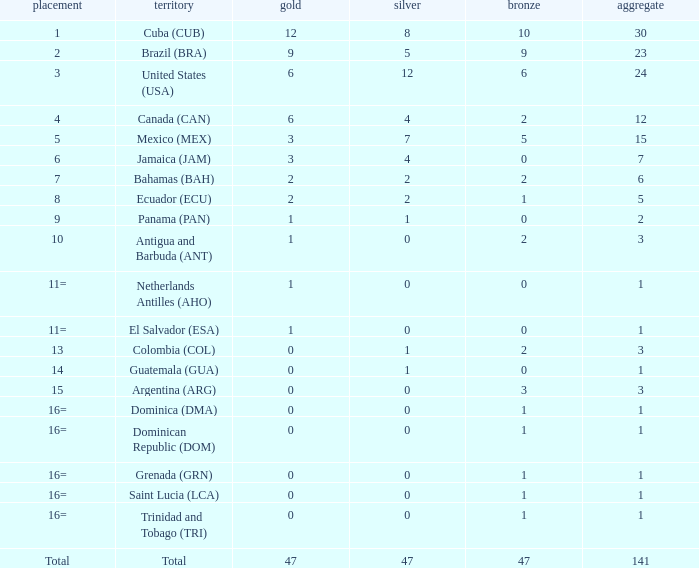What is the average silver with more than 0 gold, a Rank of 1, and a Total smaller than 30? None. 